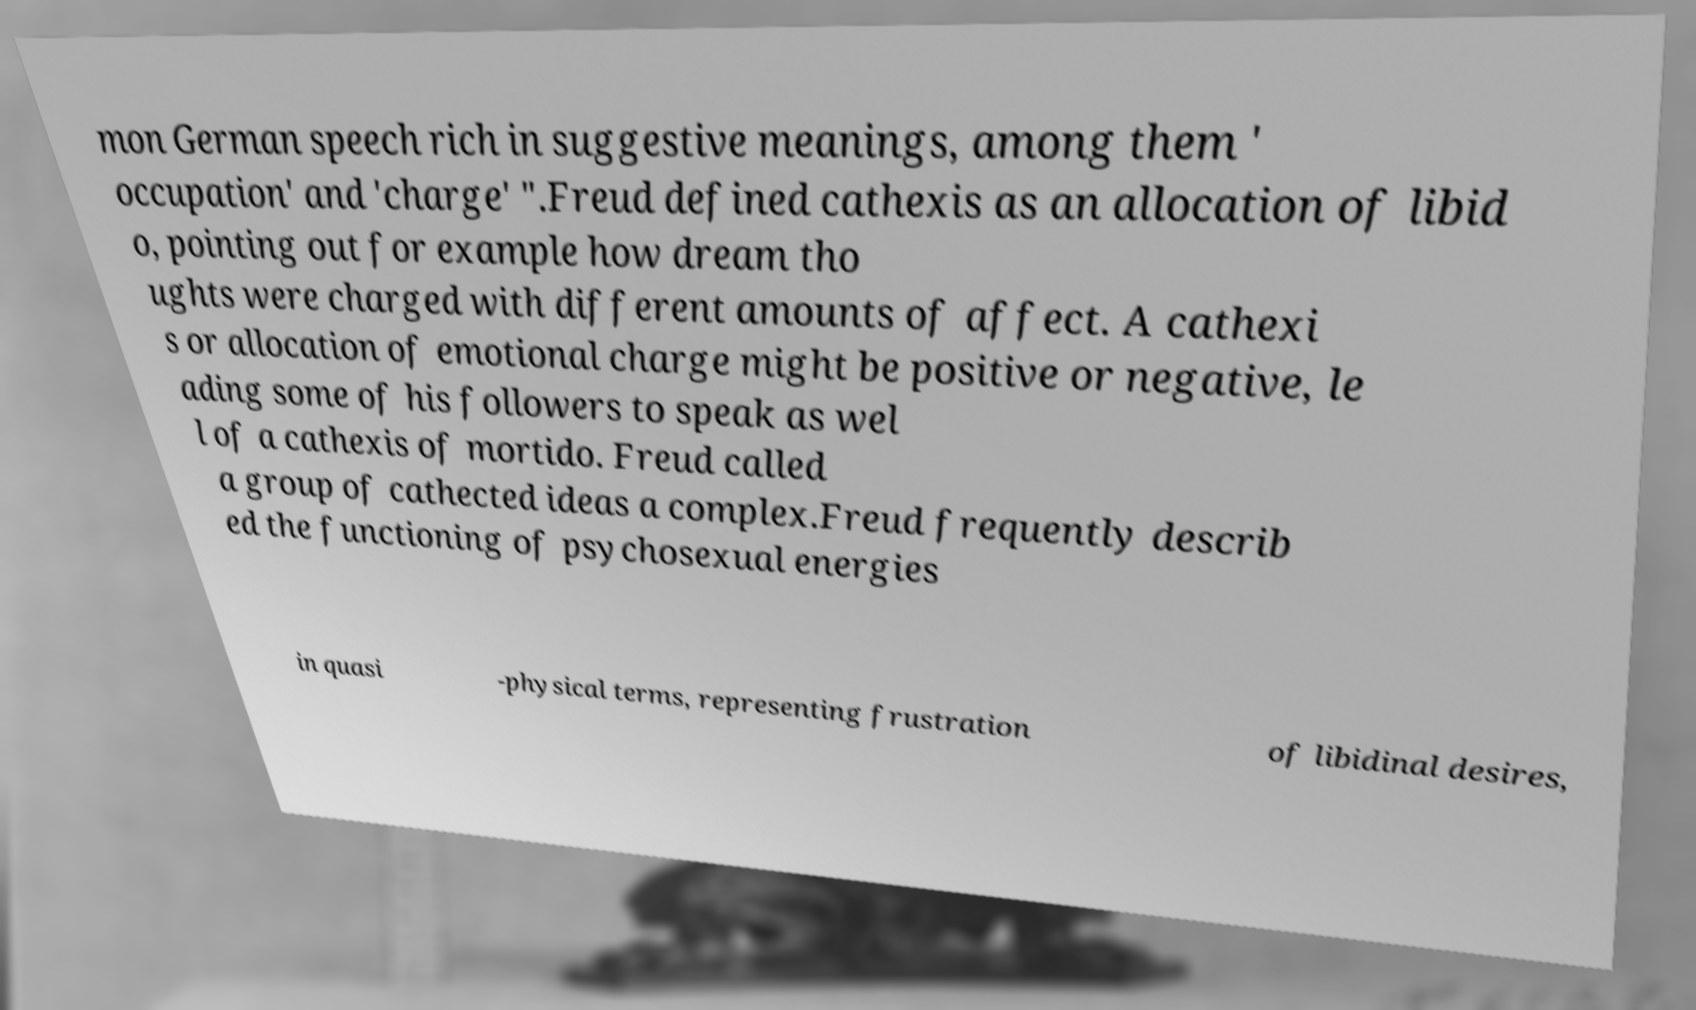Could you assist in decoding the text presented in this image and type it out clearly? mon German speech rich in suggestive meanings, among them ' occupation' and 'charge' ".Freud defined cathexis as an allocation of libid o, pointing out for example how dream tho ughts were charged with different amounts of affect. A cathexi s or allocation of emotional charge might be positive or negative, le ading some of his followers to speak as wel l of a cathexis of mortido. Freud called a group of cathected ideas a complex.Freud frequently describ ed the functioning of psychosexual energies in quasi -physical terms, representing frustration of libidinal desires, 